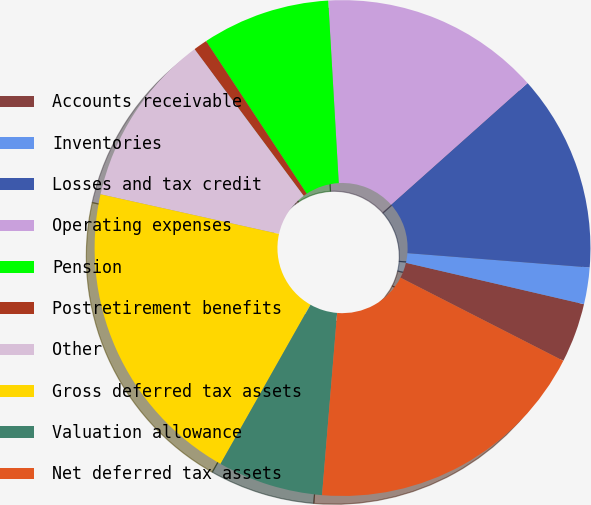Convert chart. <chart><loc_0><loc_0><loc_500><loc_500><pie_chart><fcel>Accounts receivable<fcel>Inventories<fcel>Losses and tax credit<fcel>Operating expenses<fcel>Pension<fcel>Postretirement benefits<fcel>Other<fcel>Gross deferred tax assets<fcel>Valuation allowance<fcel>Net deferred tax assets<nl><fcel>3.88%<fcel>2.39%<fcel>12.83%<fcel>14.33%<fcel>8.36%<fcel>0.9%<fcel>11.34%<fcel>20.29%<fcel>6.87%<fcel>18.8%<nl></chart> 